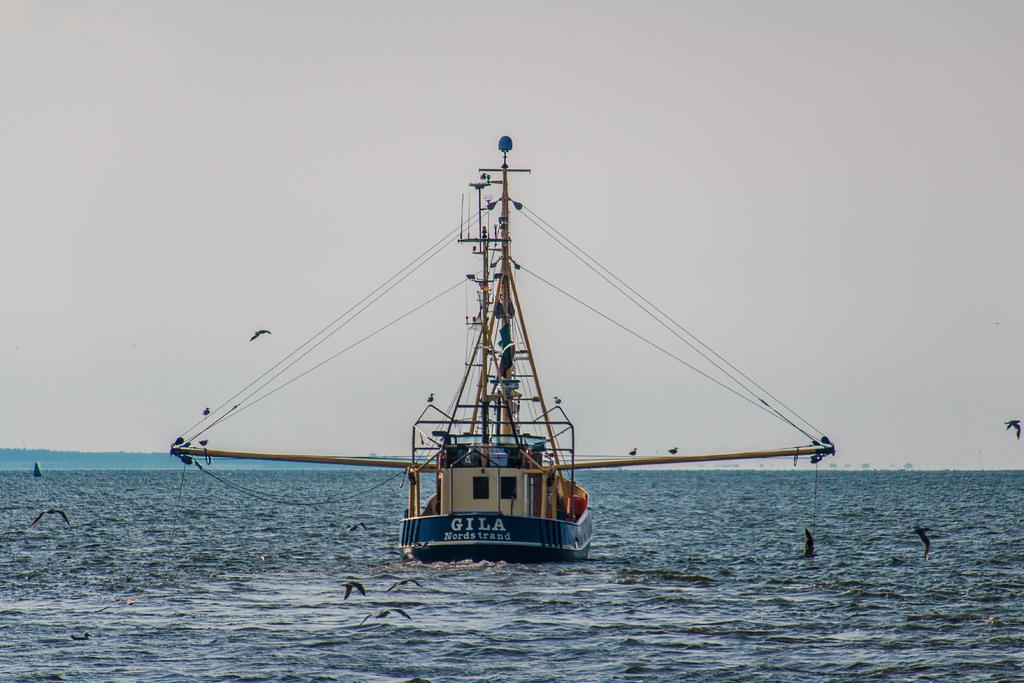Can you describe this image briefly? In this image in the center there is one ship, and in the ship there are some ropes and poles. And at the bottom there is a river and also we could see some birds, at the top there is sky. 